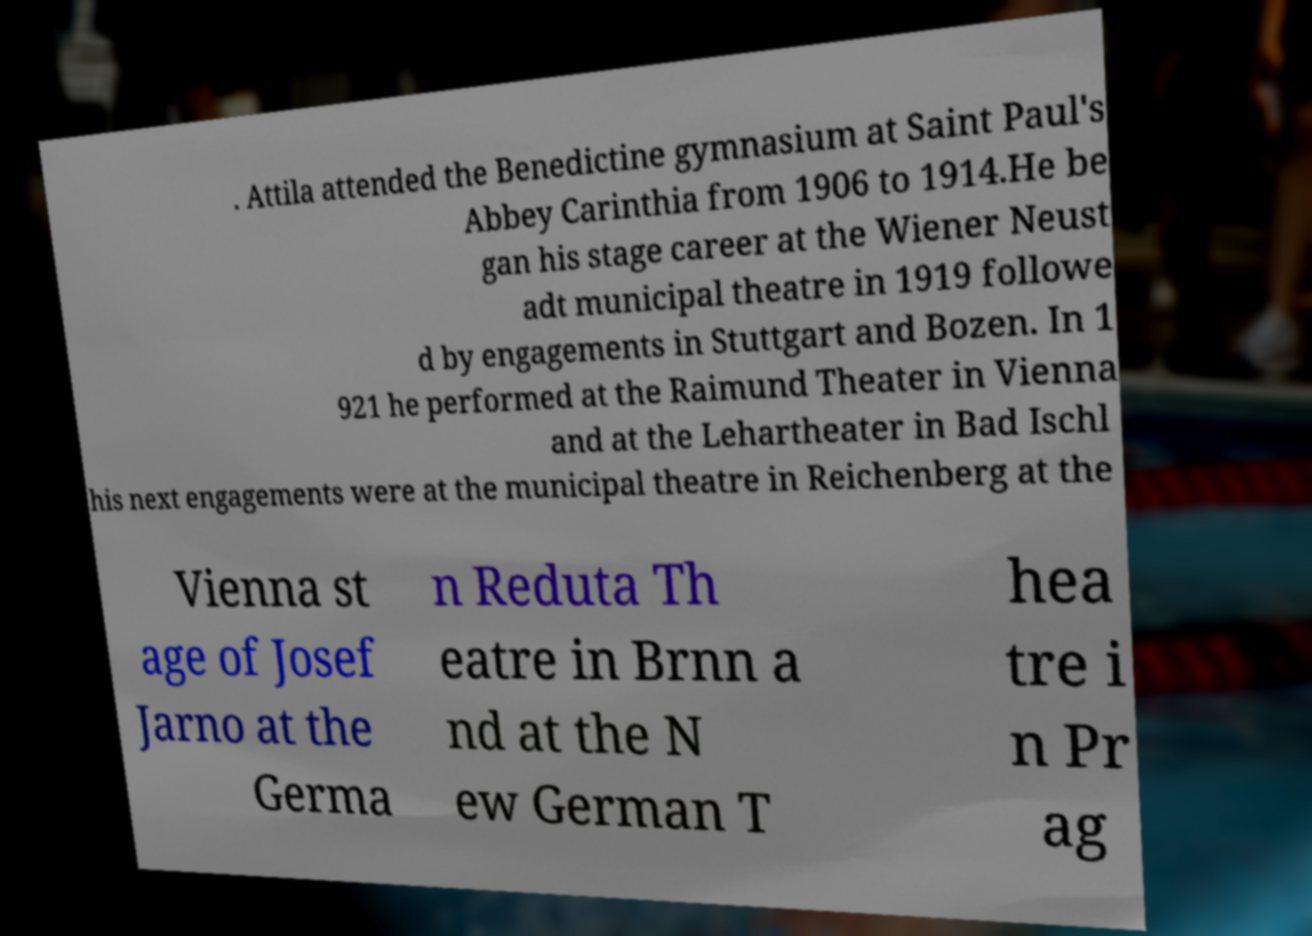Could you assist in decoding the text presented in this image and type it out clearly? . Attila attended the Benedictine gymnasium at Saint Paul's Abbey Carinthia from 1906 to 1914.He be gan his stage career at the Wiener Neust adt municipal theatre in 1919 followe d by engagements in Stuttgart and Bozen. In 1 921 he performed at the Raimund Theater in Vienna and at the Lehartheater in Bad Ischl his next engagements were at the municipal theatre in Reichenberg at the Vienna st age of Josef Jarno at the Germa n Reduta Th eatre in Brnn a nd at the N ew German T hea tre i n Pr ag 